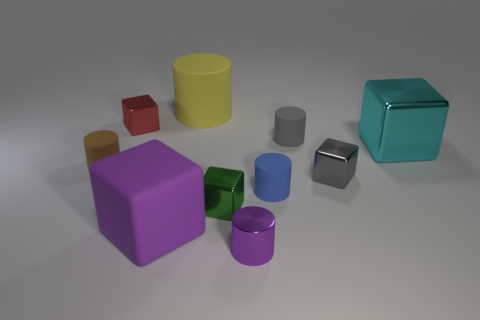Is the shape of the gray matte thing the same as the big thing that is behind the red thing?
Provide a succinct answer. Yes. There is a block that is both to the left of the large rubber cylinder and in front of the small blue rubber object; what is its size?
Ensure brevity in your answer.  Large. Is there a small cylinder that has the same material as the large cyan block?
Keep it short and to the point. Yes. There is a matte cube that is the same color as the metal cylinder; what is its size?
Offer a very short reply. Large. There is a small gray object behind the cylinder that is left of the yellow matte cylinder; what is its material?
Offer a terse response. Rubber. How many matte objects have the same color as the small metallic cylinder?
Your answer should be compact. 1. There is a purple object that is made of the same material as the gray block; what is its size?
Offer a very short reply. Small. There is a large rubber thing behind the blue thing; what is its shape?
Make the answer very short. Cylinder. There is a yellow thing that is the same shape as the brown object; what size is it?
Your answer should be very brief. Large. What number of tiny cylinders are behind the cylinder on the left side of the small metal object behind the small gray matte cylinder?
Make the answer very short. 1. 